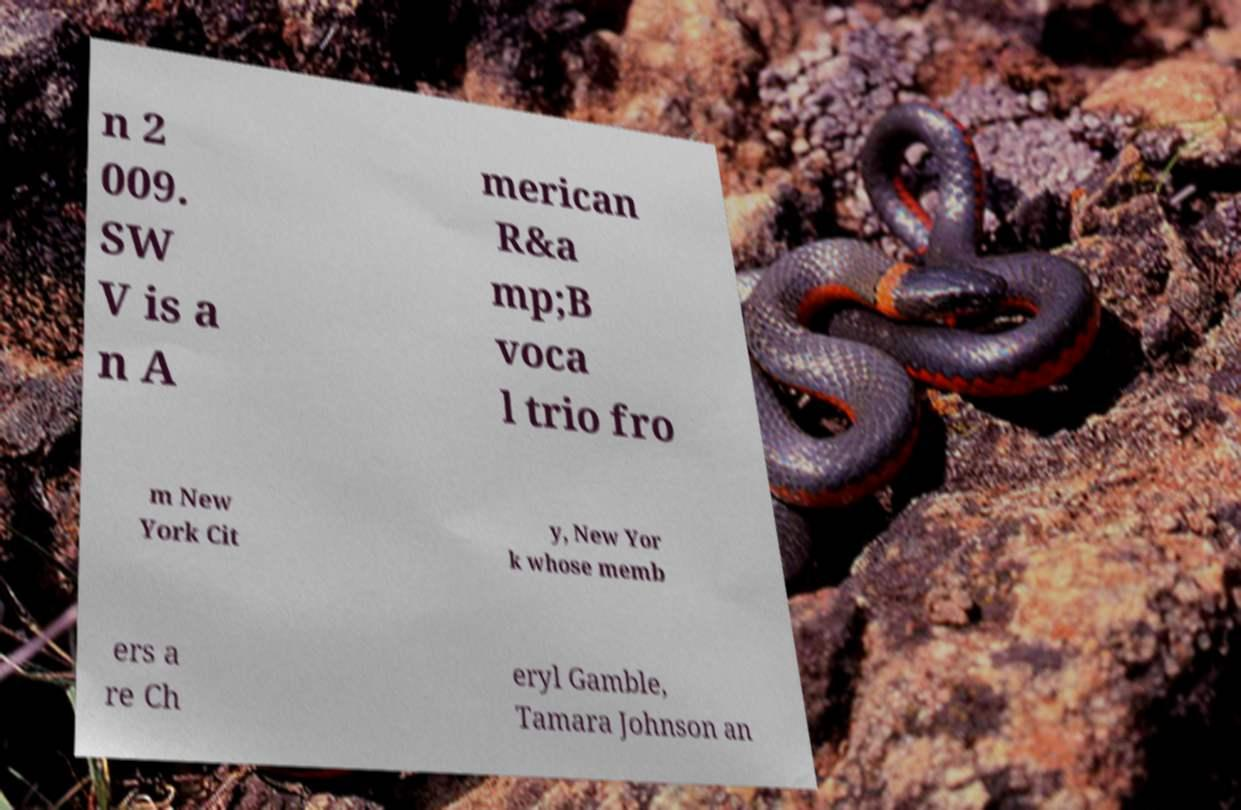Can you accurately transcribe the text from the provided image for me? n 2 009. SW V is a n A merican R&a mp;B voca l trio fro m New York Cit y, New Yor k whose memb ers a re Ch eryl Gamble, Tamara Johnson an 